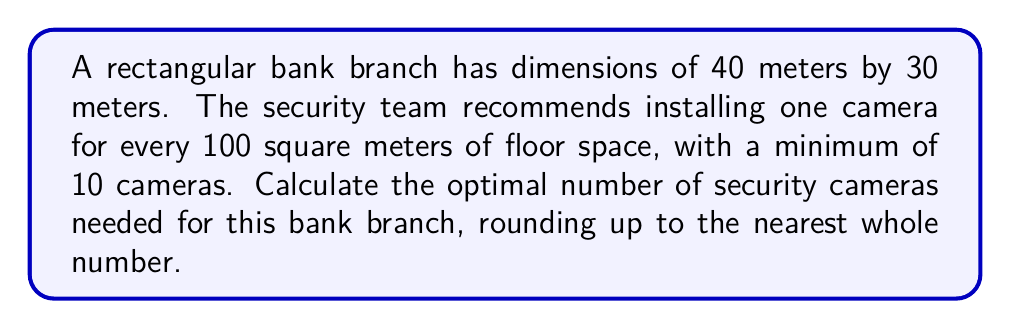Solve this math problem. To solve this problem, we'll follow these steps:

1. Calculate the total floor area of the bank:
   Area = length × width
   $A = 40 \text{ m} \times 30 \text{ m} = 1200 \text{ m}^2$

2. Calculate the number of cameras based on the recommended coverage:
   Cameras = Floor area ÷ Coverage per camera
   $C = \frac{1200 \text{ m}^2}{100 \text{ m}^2/\text{camera}} = 12 \text{ cameras}$

3. Compare with the minimum requirement:
   The calculated number (12) is greater than the minimum requirement (10), so we'll use 12.

4. Round up to the nearest whole number:
   In this case, 12 is already a whole number, so no rounding is necessary.

Therefore, the optimal number of security cameras needed for this bank branch is 12.
Answer: 12 cameras 